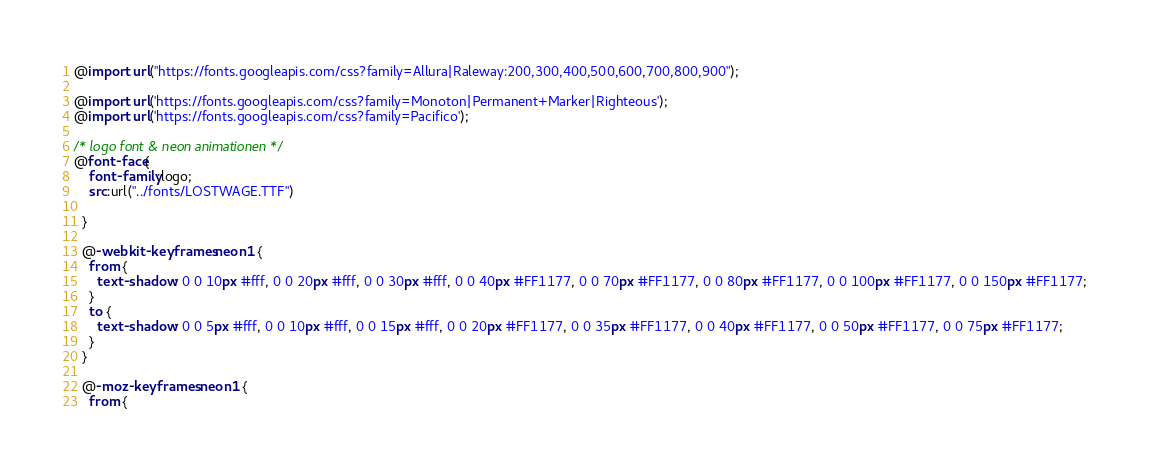Convert code to text. <code><loc_0><loc_0><loc_500><loc_500><_CSS_>@import url("https://fonts.googleapis.com/css?family=Allura|Raleway:200,300,400,500,600,700,800,900");

@import url('https://fonts.googleapis.com/css?family=Monoton|Permanent+Marker|Righteous');
@import url('https://fonts.googleapis.com/css?family=Pacifico');

/* logo font & neon animationen */
@font-face{
    font-family:logo;
    src:url("../fonts/LOSTWAGE.TTF")
  
  }
  
  @-webkit-keyframes neon1 {
    from {
      text-shadow: 0 0 10px #fff, 0 0 20px #fff, 0 0 30px #fff, 0 0 40px #FF1177, 0 0 70px #FF1177, 0 0 80px #FF1177, 0 0 100px #FF1177, 0 0 150px #FF1177;
    }
    to {
      text-shadow: 0 0 5px #fff, 0 0 10px #fff, 0 0 15px #fff, 0 0 20px #FF1177, 0 0 35px #FF1177, 0 0 40px #FF1177, 0 0 50px #FF1177, 0 0 75px #FF1177;
    }
  }
  
  @-moz-keyframes neon1 {
    from {</code> 